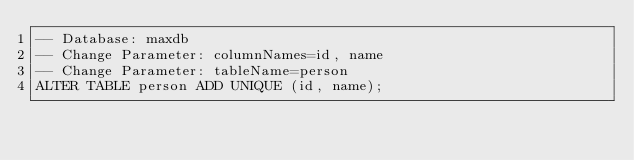Convert code to text. <code><loc_0><loc_0><loc_500><loc_500><_SQL_>-- Database: maxdb
-- Change Parameter: columnNames=id, name
-- Change Parameter: tableName=person
ALTER TABLE person ADD UNIQUE (id, name);
</code> 